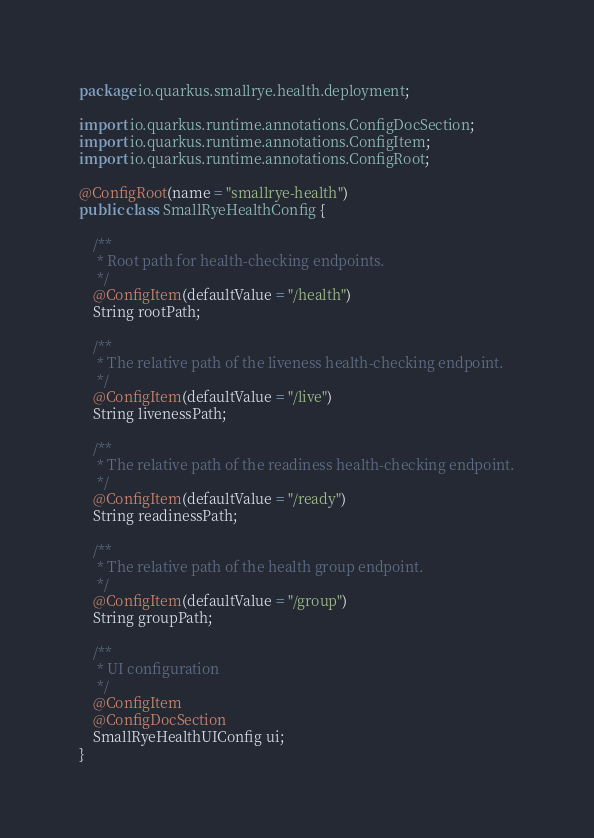Convert code to text. <code><loc_0><loc_0><loc_500><loc_500><_Java_>package io.quarkus.smallrye.health.deployment;

import io.quarkus.runtime.annotations.ConfigDocSection;
import io.quarkus.runtime.annotations.ConfigItem;
import io.quarkus.runtime.annotations.ConfigRoot;

@ConfigRoot(name = "smallrye-health")
public class SmallRyeHealthConfig {

    /**
     * Root path for health-checking endpoints.
     */
    @ConfigItem(defaultValue = "/health")
    String rootPath;

    /**
     * The relative path of the liveness health-checking endpoint.
     */
    @ConfigItem(defaultValue = "/live")
    String livenessPath;

    /**
     * The relative path of the readiness health-checking endpoint.
     */
    @ConfigItem(defaultValue = "/ready")
    String readinessPath;

    /**
     * The relative path of the health group endpoint.
     */
    @ConfigItem(defaultValue = "/group")
    String groupPath;

    /**
     * UI configuration
     */
    @ConfigItem
    @ConfigDocSection
    SmallRyeHealthUIConfig ui;
}
</code> 